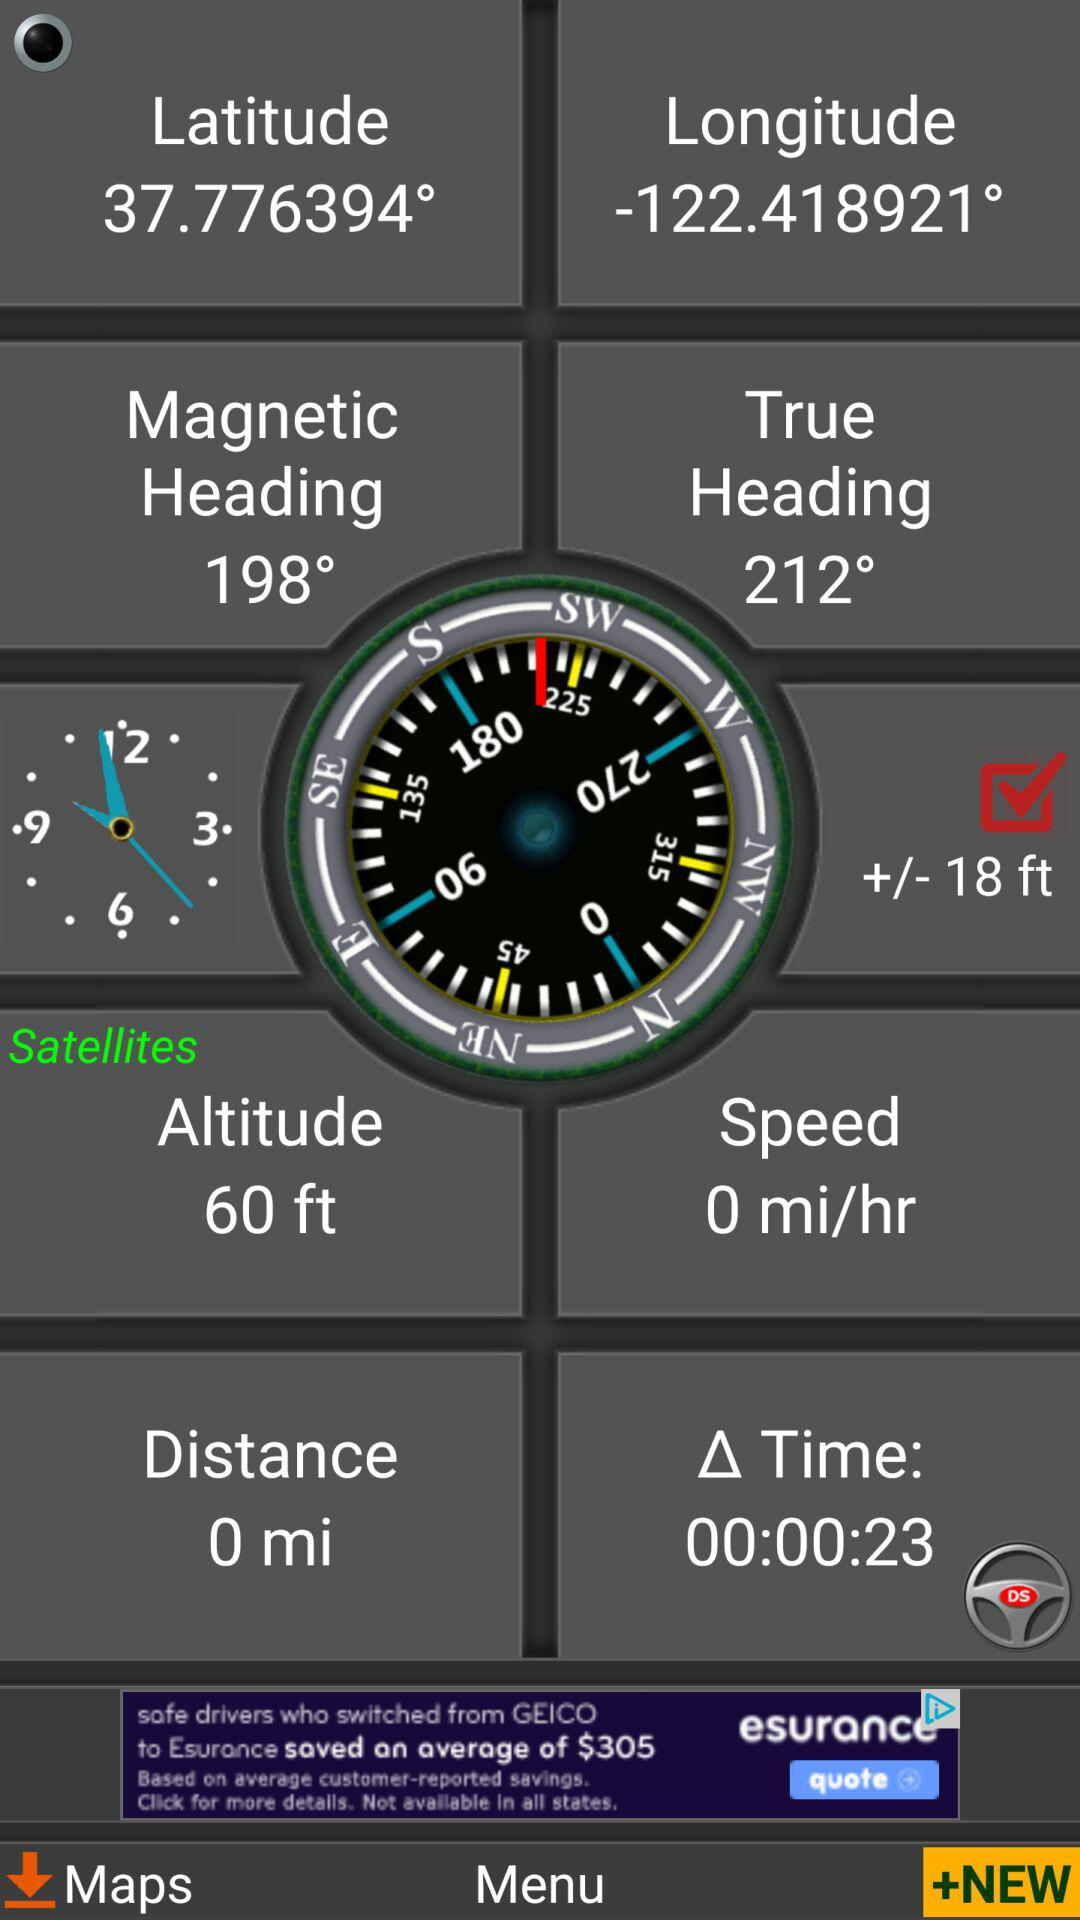What are the longitude and latitude? The longitude is -122.418921° and the latitude is 37.776394°. 